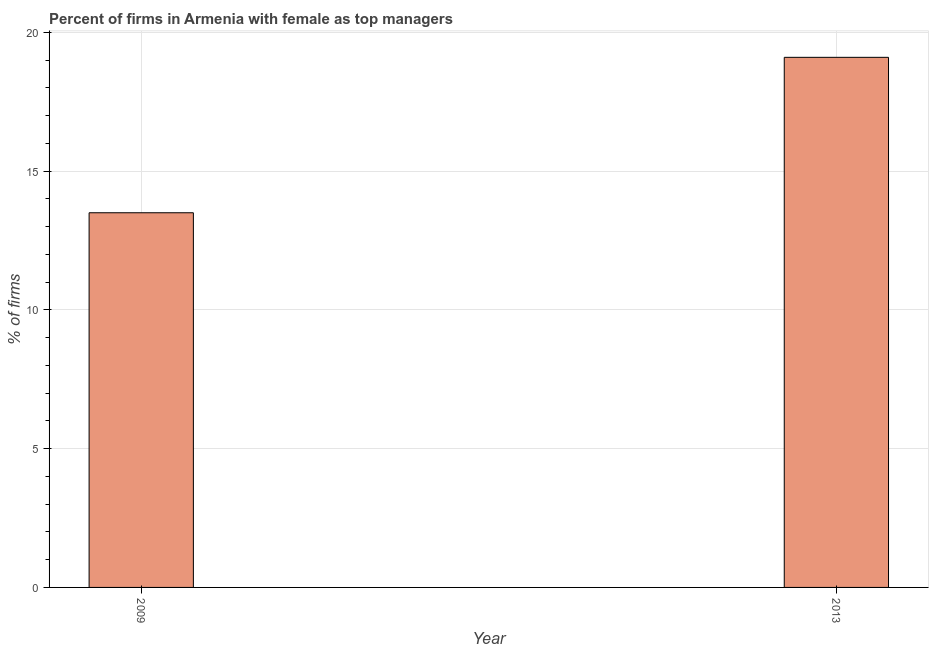Does the graph contain any zero values?
Your answer should be very brief. No. Does the graph contain grids?
Offer a very short reply. Yes. What is the title of the graph?
Give a very brief answer. Percent of firms in Armenia with female as top managers. What is the label or title of the Y-axis?
Your answer should be compact. % of firms. What is the percentage of firms with female as top manager in 2009?
Your answer should be compact. 13.5. Across all years, what is the maximum percentage of firms with female as top manager?
Offer a terse response. 19.1. Across all years, what is the minimum percentage of firms with female as top manager?
Your answer should be compact. 13.5. In which year was the percentage of firms with female as top manager maximum?
Provide a succinct answer. 2013. In which year was the percentage of firms with female as top manager minimum?
Your answer should be compact. 2009. What is the sum of the percentage of firms with female as top manager?
Keep it short and to the point. 32.6. What is the difference between the percentage of firms with female as top manager in 2009 and 2013?
Keep it short and to the point. -5.6. What is the average percentage of firms with female as top manager per year?
Offer a very short reply. 16.3. Do a majority of the years between 2009 and 2013 (inclusive) have percentage of firms with female as top manager greater than 9 %?
Keep it short and to the point. Yes. What is the ratio of the percentage of firms with female as top manager in 2009 to that in 2013?
Provide a short and direct response. 0.71. Is the percentage of firms with female as top manager in 2009 less than that in 2013?
Offer a very short reply. Yes. How many bars are there?
Offer a terse response. 2. How many years are there in the graph?
Give a very brief answer. 2. What is the difference between two consecutive major ticks on the Y-axis?
Keep it short and to the point. 5. Are the values on the major ticks of Y-axis written in scientific E-notation?
Provide a succinct answer. No. What is the % of firms in 2009?
Offer a terse response. 13.5. What is the % of firms in 2013?
Your answer should be compact. 19.1. What is the ratio of the % of firms in 2009 to that in 2013?
Ensure brevity in your answer.  0.71. 